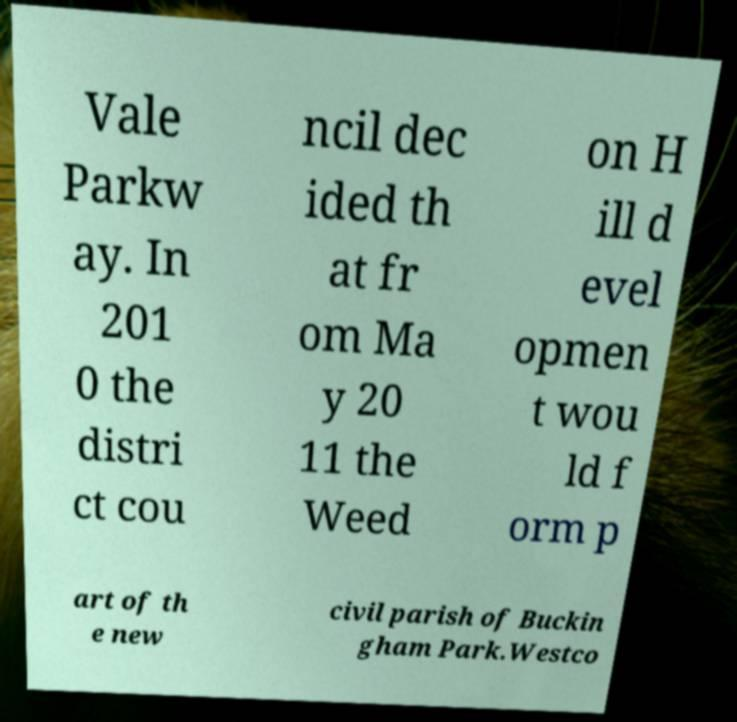Can you read and provide the text displayed in the image?This photo seems to have some interesting text. Can you extract and type it out for me? Vale Parkw ay. In 201 0 the distri ct cou ncil dec ided th at fr om Ma y 20 11 the Weed on H ill d evel opmen t wou ld f orm p art of th e new civil parish of Buckin gham Park.Westco 